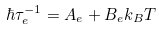Convert formula to latex. <formula><loc_0><loc_0><loc_500><loc_500>\hbar { \tau } _ { e } ^ { - 1 } = A _ { e } + B _ { e } k _ { B } T</formula> 